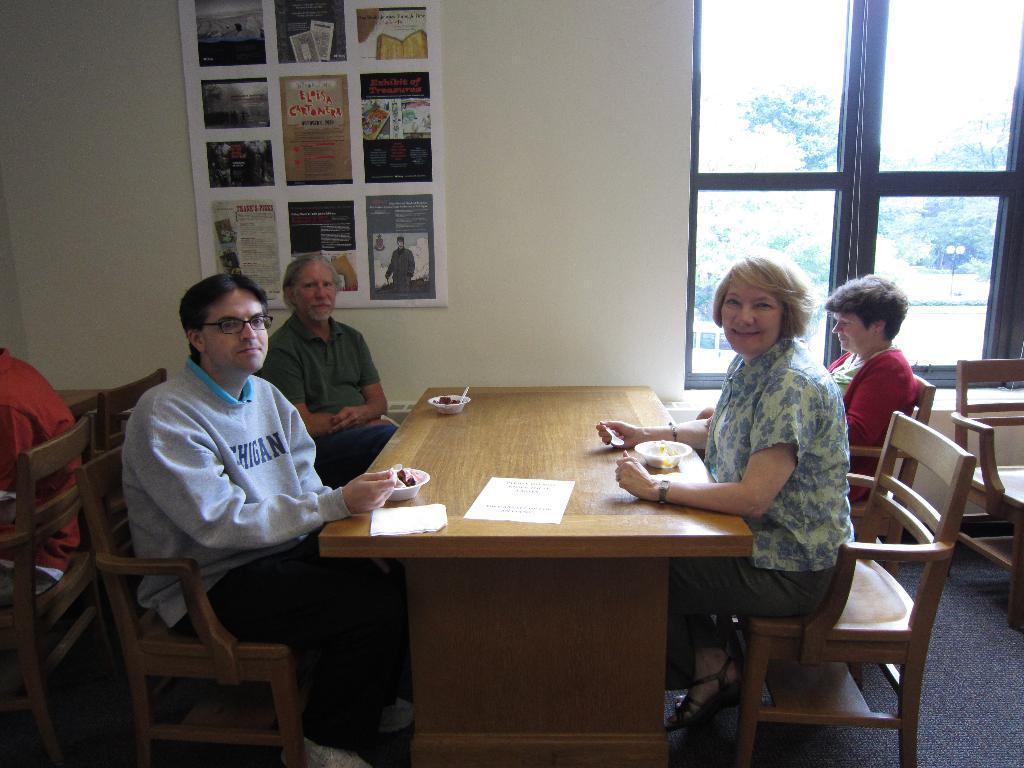Can you describe this image briefly? Here we can see a group of people sitting on chairs with table in front of them and there are papers and bowls of food present on the table and behind them on the right side there is a window from which we can see the greenery outside and on the wall this some kind of poster 